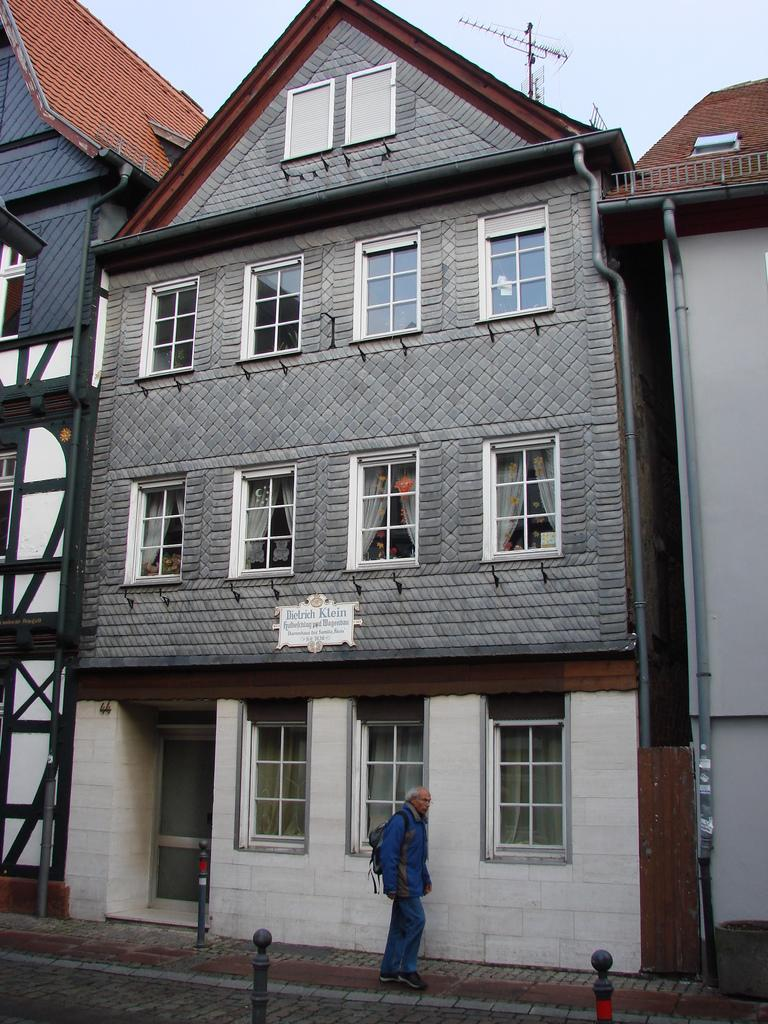What type of structures can be seen in the background of the image? There are buildings with many windows in the background of the image. What is happening in front of the buildings? There is a person walking in front of the buildings. What can be seen above the buildings? The sky is visible above the buildings. Can you tell me how many lamps are on the person walking in the image? There is no mention of lamps in the image; it features a person walking in front of buildings with many windows. Is the person's mom visible in the image? There is no mention of the person's mom in the image; it only shows a person walking in front of buildings with many windows. 